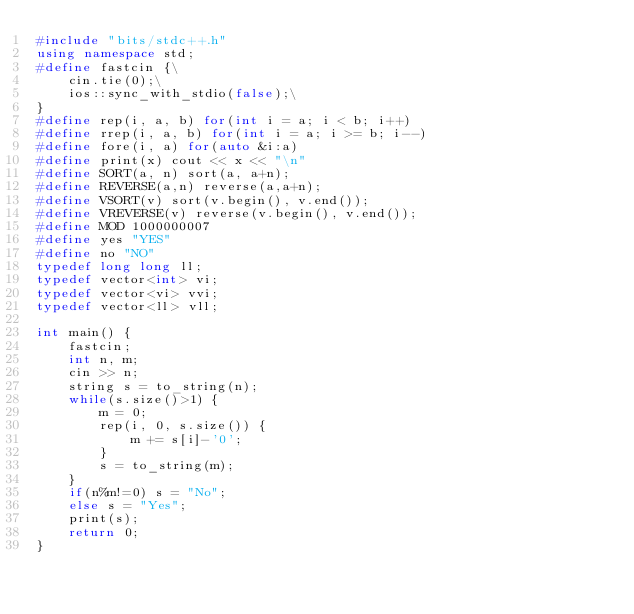<code> <loc_0><loc_0><loc_500><loc_500><_C++_>#include "bits/stdc++.h"
using namespace std;
#define fastcin {\
    cin.tie(0);\
    ios::sync_with_stdio(false);\
}
#define rep(i, a, b) for(int i = a; i < b; i++)
#define rrep(i, a, b) for(int i = a; i >= b; i--)
#define fore(i, a) for(auto &i:a)
#define print(x) cout << x << "\n"
#define SORT(a, n) sort(a, a+n);
#define REVERSE(a,n) reverse(a,a+n);
#define VSORT(v) sort(v.begin(), v.end());
#define VREVERSE(v) reverse(v.begin(), v.end());
#define MOD 1000000007
#define yes "YES"
#define no "NO"
typedef long long ll;
typedef vector<int> vi;
typedef vector<vi> vvi;
typedef vector<ll> vll;

int main() {
    fastcin;
    int n, m;
    cin >> n;
    string s = to_string(n);
    while(s.size()>1) {
        m = 0;
        rep(i, 0, s.size()) {
            m += s[i]-'0';
        }
        s = to_string(m);
    }
    if(n%m!=0) s = "No";
    else s = "Yes";
    print(s);
    return 0;
}</code> 